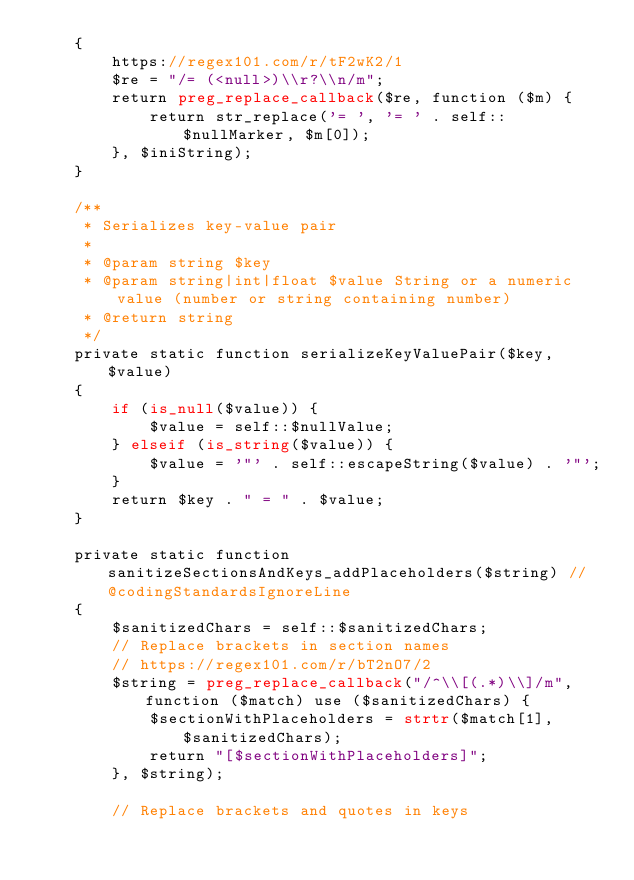<code> <loc_0><loc_0><loc_500><loc_500><_PHP_>    {
        https://regex101.com/r/tF2wK2/1
        $re = "/= (<null>)\\r?\\n/m";
        return preg_replace_callback($re, function ($m) {
            return str_replace('= ', '= ' . self::$nullMarker, $m[0]);
        }, $iniString);
    }

    /**
     * Serializes key-value pair
     *
     * @param string $key
     * @param string|int|float $value String or a numeric value (number or string containing number)
     * @return string
     */
    private static function serializeKeyValuePair($key, $value)
    {
        if (is_null($value)) {
            $value = self::$nullValue;
        } elseif (is_string($value)) {
            $value = '"' . self::escapeString($value) . '"';
        }
        return $key . " = " . $value;
    }

    private static function sanitizeSectionsAndKeys_addPlaceholders($string) // @codingStandardsIgnoreLine
    {
        $sanitizedChars = self::$sanitizedChars;
        // Replace brackets in section names
        // https://regex101.com/r/bT2nO7/2
        $string = preg_replace_callback("/^\\[(.*)\\]/m", function ($match) use ($sanitizedChars) {
            $sectionWithPlaceholders = strtr($match[1], $sanitizedChars);
            return "[$sectionWithPlaceholders]";
        }, $string);

        // Replace brackets and quotes in keys</code> 